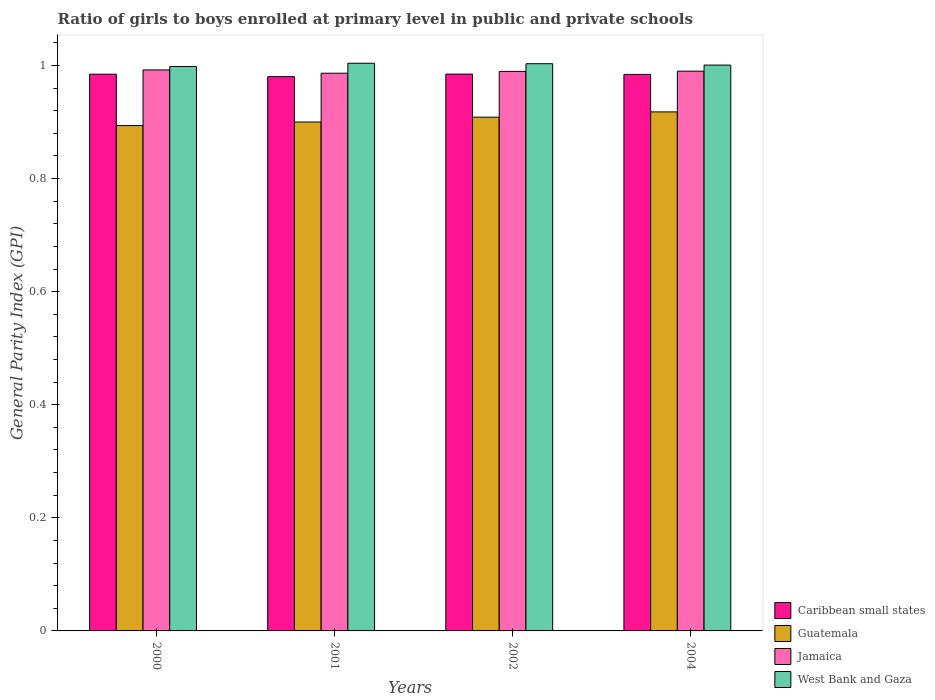How many different coloured bars are there?
Ensure brevity in your answer.  4. How many groups of bars are there?
Provide a short and direct response. 4. How many bars are there on the 2nd tick from the right?
Offer a terse response. 4. What is the general parity index in Guatemala in 2001?
Your answer should be compact. 0.9. Across all years, what is the maximum general parity index in West Bank and Gaza?
Give a very brief answer. 1. Across all years, what is the minimum general parity index in Guatemala?
Give a very brief answer. 0.89. In which year was the general parity index in Caribbean small states minimum?
Provide a succinct answer. 2001. What is the total general parity index in Jamaica in the graph?
Offer a terse response. 3.96. What is the difference between the general parity index in West Bank and Gaza in 2000 and that in 2002?
Your answer should be very brief. -0. What is the difference between the general parity index in West Bank and Gaza in 2000 and the general parity index in Caribbean small states in 2001?
Your answer should be very brief. 0.02. What is the average general parity index in Guatemala per year?
Your answer should be very brief. 0.91. In the year 2002, what is the difference between the general parity index in Jamaica and general parity index in Guatemala?
Offer a very short reply. 0.08. In how many years, is the general parity index in Jamaica greater than 0.08?
Offer a terse response. 4. What is the ratio of the general parity index in West Bank and Gaza in 2000 to that in 2004?
Make the answer very short. 1. What is the difference between the highest and the second highest general parity index in Caribbean small states?
Offer a terse response. 0. What is the difference between the highest and the lowest general parity index in Caribbean small states?
Provide a short and direct response. 0. Is it the case that in every year, the sum of the general parity index in Caribbean small states and general parity index in Jamaica is greater than the sum of general parity index in West Bank and Gaza and general parity index in Guatemala?
Offer a terse response. Yes. What does the 3rd bar from the left in 2004 represents?
Offer a very short reply. Jamaica. What does the 2nd bar from the right in 2004 represents?
Offer a terse response. Jamaica. Is it the case that in every year, the sum of the general parity index in Jamaica and general parity index in Caribbean small states is greater than the general parity index in West Bank and Gaza?
Ensure brevity in your answer.  Yes. How many bars are there?
Provide a succinct answer. 16. What is the difference between two consecutive major ticks on the Y-axis?
Give a very brief answer. 0.2. Does the graph contain any zero values?
Offer a very short reply. No. What is the title of the graph?
Your answer should be very brief. Ratio of girls to boys enrolled at primary level in public and private schools. What is the label or title of the X-axis?
Provide a short and direct response. Years. What is the label or title of the Y-axis?
Offer a terse response. General Parity Index (GPI). What is the General Parity Index (GPI) of Caribbean small states in 2000?
Make the answer very short. 0.98. What is the General Parity Index (GPI) of Guatemala in 2000?
Provide a succinct answer. 0.89. What is the General Parity Index (GPI) in Jamaica in 2000?
Make the answer very short. 0.99. What is the General Parity Index (GPI) in West Bank and Gaza in 2000?
Give a very brief answer. 1. What is the General Parity Index (GPI) in Caribbean small states in 2001?
Your response must be concise. 0.98. What is the General Parity Index (GPI) of Guatemala in 2001?
Provide a short and direct response. 0.9. What is the General Parity Index (GPI) of Jamaica in 2001?
Offer a terse response. 0.99. What is the General Parity Index (GPI) of West Bank and Gaza in 2001?
Your answer should be compact. 1. What is the General Parity Index (GPI) of Caribbean small states in 2002?
Your answer should be compact. 0.98. What is the General Parity Index (GPI) in Guatemala in 2002?
Your answer should be compact. 0.91. What is the General Parity Index (GPI) of Jamaica in 2002?
Make the answer very short. 0.99. What is the General Parity Index (GPI) in West Bank and Gaza in 2002?
Offer a very short reply. 1. What is the General Parity Index (GPI) of Caribbean small states in 2004?
Keep it short and to the point. 0.98. What is the General Parity Index (GPI) in Guatemala in 2004?
Provide a succinct answer. 0.92. What is the General Parity Index (GPI) in Jamaica in 2004?
Your answer should be very brief. 0.99. What is the General Parity Index (GPI) of West Bank and Gaza in 2004?
Give a very brief answer. 1. Across all years, what is the maximum General Parity Index (GPI) of Caribbean small states?
Ensure brevity in your answer.  0.98. Across all years, what is the maximum General Parity Index (GPI) in Guatemala?
Provide a succinct answer. 0.92. Across all years, what is the maximum General Parity Index (GPI) in Jamaica?
Ensure brevity in your answer.  0.99. Across all years, what is the maximum General Parity Index (GPI) in West Bank and Gaza?
Give a very brief answer. 1. Across all years, what is the minimum General Parity Index (GPI) of Caribbean small states?
Provide a short and direct response. 0.98. Across all years, what is the minimum General Parity Index (GPI) of Guatemala?
Offer a terse response. 0.89. Across all years, what is the minimum General Parity Index (GPI) of Jamaica?
Your answer should be very brief. 0.99. Across all years, what is the minimum General Parity Index (GPI) in West Bank and Gaza?
Your response must be concise. 1. What is the total General Parity Index (GPI) of Caribbean small states in the graph?
Keep it short and to the point. 3.93. What is the total General Parity Index (GPI) in Guatemala in the graph?
Ensure brevity in your answer.  3.62. What is the total General Parity Index (GPI) of Jamaica in the graph?
Your response must be concise. 3.96. What is the total General Parity Index (GPI) of West Bank and Gaza in the graph?
Offer a very short reply. 4.01. What is the difference between the General Parity Index (GPI) in Caribbean small states in 2000 and that in 2001?
Keep it short and to the point. 0. What is the difference between the General Parity Index (GPI) of Guatemala in 2000 and that in 2001?
Your answer should be compact. -0.01. What is the difference between the General Parity Index (GPI) in Jamaica in 2000 and that in 2001?
Make the answer very short. 0.01. What is the difference between the General Parity Index (GPI) in West Bank and Gaza in 2000 and that in 2001?
Offer a terse response. -0.01. What is the difference between the General Parity Index (GPI) in Caribbean small states in 2000 and that in 2002?
Offer a terse response. -0. What is the difference between the General Parity Index (GPI) in Guatemala in 2000 and that in 2002?
Provide a succinct answer. -0.01. What is the difference between the General Parity Index (GPI) in Jamaica in 2000 and that in 2002?
Make the answer very short. 0. What is the difference between the General Parity Index (GPI) of West Bank and Gaza in 2000 and that in 2002?
Keep it short and to the point. -0. What is the difference between the General Parity Index (GPI) of Caribbean small states in 2000 and that in 2004?
Your answer should be very brief. 0. What is the difference between the General Parity Index (GPI) of Guatemala in 2000 and that in 2004?
Give a very brief answer. -0.02. What is the difference between the General Parity Index (GPI) of Jamaica in 2000 and that in 2004?
Provide a succinct answer. 0. What is the difference between the General Parity Index (GPI) in West Bank and Gaza in 2000 and that in 2004?
Keep it short and to the point. -0. What is the difference between the General Parity Index (GPI) in Caribbean small states in 2001 and that in 2002?
Make the answer very short. -0. What is the difference between the General Parity Index (GPI) in Guatemala in 2001 and that in 2002?
Provide a short and direct response. -0.01. What is the difference between the General Parity Index (GPI) in Jamaica in 2001 and that in 2002?
Give a very brief answer. -0. What is the difference between the General Parity Index (GPI) of West Bank and Gaza in 2001 and that in 2002?
Offer a terse response. 0. What is the difference between the General Parity Index (GPI) in Caribbean small states in 2001 and that in 2004?
Keep it short and to the point. -0. What is the difference between the General Parity Index (GPI) of Guatemala in 2001 and that in 2004?
Give a very brief answer. -0.02. What is the difference between the General Parity Index (GPI) of Jamaica in 2001 and that in 2004?
Your response must be concise. -0. What is the difference between the General Parity Index (GPI) in West Bank and Gaza in 2001 and that in 2004?
Provide a short and direct response. 0. What is the difference between the General Parity Index (GPI) of Caribbean small states in 2002 and that in 2004?
Ensure brevity in your answer.  0. What is the difference between the General Parity Index (GPI) in Guatemala in 2002 and that in 2004?
Keep it short and to the point. -0.01. What is the difference between the General Parity Index (GPI) of Jamaica in 2002 and that in 2004?
Your answer should be very brief. -0. What is the difference between the General Parity Index (GPI) in West Bank and Gaza in 2002 and that in 2004?
Ensure brevity in your answer.  0. What is the difference between the General Parity Index (GPI) of Caribbean small states in 2000 and the General Parity Index (GPI) of Guatemala in 2001?
Offer a very short reply. 0.08. What is the difference between the General Parity Index (GPI) of Caribbean small states in 2000 and the General Parity Index (GPI) of Jamaica in 2001?
Provide a succinct answer. -0. What is the difference between the General Parity Index (GPI) of Caribbean small states in 2000 and the General Parity Index (GPI) of West Bank and Gaza in 2001?
Provide a short and direct response. -0.02. What is the difference between the General Parity Index (GPI) in Guatemala in 2000 and the General Parity Index (GPI) in Jamaica in 2001?
Your answer should be compact. -0.09. What is the difference between the General Parity Index (GPI) in Guatemala in 2000 and the General Parity Index (GPI) in West Bank and Gaza in 2001?
Your answer should be compact. -0.11. What is the difference between the General Parity Index (GPI) in Jamaica in 2000 and the General Parity Index (GPI) in West Bank and Gaza in 2001?
Provide a short and direct response. -0.01. What is the difference between the General Parity Index (GPI) in Caribbean small states in 2000 and the General Parity Index (GPI) in Guatemala in 2002?
Your answer should be very brief. 0.08. What is the difference between the General Parity Index (GPI) of Caribbean small states in 2000 and the General Parity Index (GPI) of Jamaica in 2002?
Make the answer very short. -0.01. What is the difference between the General Parity Index (GPI) of Caribbean small states in 2000 and the General Parity Index (GPI) of West Bank and Gaza in 2002?
Offer a very short reply. -0.02. What is the difference between the General Parity Index (GPI) in Guatemala in 2000 and the General Parity Index (GPI) in Jamaica in 2002?
Your answer should be very brief. -0.1. What is the difference between the General Parity Index (GPI) in Guatemala in 2000 and the General Parity Index (GPI) in West Bank and Gaza in 2002?
Make the answer very short. -0.11. What is the difference between the General Parity Index (GPI) of Jamaica in 2000 and the General Parity Index (GPI) of West Bank and Gaza in 2002?
Ensure brevity in your answer.  -0.01. What is the difference between the General Parity Index (GPI) in Caribbean small states in 2000 and the General Parity Index (GPI) in Guatemala in 2004?
Make the answer very short. 0.07. What is the difference between the General Parity Index (GPI) in Caribbean small states in 2000 and the General Parity Index (GPI) in Jamaica in 2004?
Your response must be concise. -0.01. What is the difference between the General Parity Index (GPI) in Caribbean small states in 2000 and the General Parity Index (GPI) in West Bank and Gaza in 2004?
Provide a succinct answer. -0.02. What is the difference between the General Parity Index (GPI) in Guatemala in 2000 and the General Parity Index (GPI) in Jamaica in 2004?
Ensure brevity in your answer.  -0.1. What is the difference between the General Parity Index (GPI) in Guatemala in 2000 and the General Parity Index (GPI) in West Bank and Gaza in 2004?
Give a very brief answer. -0.11. What is the difference between the General Parity Index (GPI) in Jamaica in 2000 and the General Parity Index (GPI) in West Bank and Gaza in 2004?
Offer a terse response. -0.01. What is the difference between the General Parity Index (GPI) of Caribbean small states in 2001 and the General Parity Index (GPI) of Guatemala in 2002?
Keep it short and to the point. 0.07. What is the difference between the General Parity Index (GPI) of Caribbean small states in 2001 and the General Parity Index (GPI) of Jamaica in 2002?
Your response must be concise. -0.01. What is the difference between the General Parity Index (GPI) in Caribbean small states in 2001 and the General Parity Index (GPI) in West Bank and Gaza in 2002?
Offer a very short reply. -0.02. What is the difference between the General Parity Index (GPI) in Guatemala in 2001 and the General Parity Index (GPI) in Jamaica in 2002?
Your answer should be compact. -0.09. What is the difference between the General Parity Index (GPI) of Guatemala in 2001 and the General Parity Index (GPI) of West Bank and Gaza in 2002?
Give a very brief answer. -0.1. What is the difference between the General Parity Index (GPI) in Jamaica in 2001 and the General Parity Index (GPI) in West Bank and Gaza in 2002?
Keep it short and to the point. -0.02. What is the difference between the General Parity Index (GPI) in Caribbean small states in 2001 and the General Parity Index (GPI) in Guatemala in 2004?
Your response must be concise. 0.06. What is the difference between the General Parity Index (GPI) in Caribbean small states in 2001 and the General Parity Index (GPI) in Jamaica in 2004?
Provide a short and direct response. -0.01. What is the difference between the General Parity Index (GPI) in Caribbean small states in 2001 and the General Parity Index (GPI) in West Bank and Gaza in 2004?
Provide a succinct answer. -0.02. What is the difference between the General Parity Index (GPI) in Guatemala in 2001 and the General Parity Index (GPI) in Jamaica in 2004?
Provide a succinct answer. -0.09. What is the difference between the General Parity Index (GPI) of Guatemala in 2001 and the General Parity Index (GPI) of West Bank and Gaza in 2004?
Your answer should be very brief. -0.1. What is the difference between the General Parity Index (GPI) of Jamaica in 2001 and the General Parity Index (GPI) of West Bank and Gaza in 2004?
Provide a succinct answer. -0.01. What is the difference between the General Parity Index (GPI) of Caribbean small states in 2002 and the General Parity Index (GPI) of Guatemala in 2004?
Make the answer very short. 0.07. What is the difference between the General Parity Index (GPI) in Caribbean small states in 2002 and the General Parity Index (GPI) in Jamaica in 2004?
Your answer should be compact. -0.01. What is the difference between the General Parity Index (GPI) of Caribbean small states in 2002 and the General Parity Index (GPI) of West Bank and Gaza in 2004?
Ensure brevity in your answer.  -0.02. What is the difference between the General Parity Index (GPI) in Guatemala in 2002 and the General Parity Index (GPI) in Jamaica in 2004?
Provide a succinct answer. -0.08. What is the difference between the General Parity Index (GPI) of Guatemala in 2002 and the General Parity Index (GPI) of West Bank and Gaza in 2004?
Your answer should be very brief. -0.09. What is the difference between the General Parity Index (GPI) of Jamaica in 2002 and the General Parity Index (GPI) of West Bank and Gaza in 2004?
Provide a succinct answer. -0.01. What is the average General Parity Index (GPI) in Caribbean small states per year?
Make the answer very short. 0.98. What is the average General Parity Index (GPI) in Guatemala per year?
Make the answer very short. 0.91. What is the average General Parity Index (GPI) in Jamaica per year?
Provide a succinct answer. 0.99. In the year 2000, what is the difference between the General Parity Index (GPI) in Caribbean small states and General Parity Index (GPI) in Guatemala?
Offer a terse response. 0.09. In the year 2000, what is the difference between the General Parity Index (GPI) in Caribbean small states and General Parity Index (GPI) in Jamaica?
Keep it short and to the point. -0.01. In the year 2000, what is the difference between the General Parity Index (GPI) in Caribbean small states and General Parity Index (GPI) in West Bank and Gaza?
Make the answer very short. -0.01. In the year 2000, what is the difference between the General Parity Index (GPI) in Guatemala and General Parity Index (GPI) in Jamaica?
Keep it short and to the point. -0.1. In the year 2000, what is the difference between the General Parity Index (GPI) of Guatemala and General Parity Index (GPI) of West Bank and Gaza?
Keep it short and to the point. -0.1. In the year 2000, what is the difference between the General Parity Index (GPI) of Jamaica and General Parity Index (GPI) of West Bank and Gaza?
Make the answer very short. -0.01. In the year 2001, what is the difference between the General Parity Index (GPI) of Caribbean small states and General Parity Index (GPI) of Guatemala?
Your answer should be very brief. 0.08. In the year 2001, what is the difference between the General Parity Index (GPI) of Caribbean small states and General Parity Index (GPI) of Jamaica?
Offer a very short reply. -0.01. In the year 2001, what is the difference between the General Parity Index (GPI) in Caribbean small states and General Parity Index (GPI) in West Bank and Gaza?
Provide a short and direct response. -0.02. In the year 2001, what is the difference between the General Parity Index (GPI) in Guatemala and General Parity Index (GPI) in Jamaica?
Ensure brevity in your answer.  -0.09. In the year 2001, what is the difference between the General Parity Index (GPI) of Guatemala and General Parity Index (GPI) of West Bank and Gaza?
Give a very brief answer. -0.1. In the year 2001, what is the difference between the General Parity Index (GPI) in Jamaica and General Parity Index (GPI) in West Bank and Gaza?
Provide a short and direct response. -0.02. In the year 2002, what is the difference between the General Parity Index (GPI) of Caribbean small states and General Parity Index (GPI) of Guatemala?
Offer a very short reply. 0.08. In the year 2002, what is the difference between the General Parity Index (GPI) of Caribbean small states and General Parity Index (GPI) of Jamaica?
Your response must be concise. -0. In the year 2002, what is the difference between the General Parity Index (GPI) in Caribbean small states and General Parity Index (GPI) in West Bank and Gaza?
Ensure brevity in your answer.  -0.02. In the year 2002, what is the difference between the General Parity Index (GPI) in Guatemala and General Parity Index (GPI) in Jamaica?
Your answer should be very brief. -0.08. In the year 2002, what is the difference between the General Parity Index (GPI) in Guatemala and General Parity Index (GPI) in West Bank and Gaza?
Give a very brief answer. -0.09. In the year 2002, what is the difference between the General Parity Index (GPI) in Jamaica and General Parity Index (GPI) in West Bank and Gaza?
Give a very brief answer. -0.01. In the year 2004, what is the difference between the General Parity Index (GPI) of Caribbean small states and General Parity Index (GPI) of Guatemala?
Your response must be concise. 0.07. In the year 2004, what is the difference between the General Parity Index (GPI) in Caribbean small states and General Parity Index (GPI) in Jamaica?
Keep it short and to the point. -0.01. In the year 2004, what is the difference between the General Parity Index (GPI) in Caribbean small states and General Parity Index (GPI) in West Bank and Gaza?
Your response must be concise. -0.02. In the year 2004, what is the difference between the General Parity Index (GPI) of Guatemala and General Parity Index (GPI) of Jamaica?
Make the answer very short. -0.07. In the year 2004, what is the difference between the General Parity Index (GPI) of Guatemala and General Parity Index (GPI) of West Bank and Gaza?
Your answer should be compact. -0.08. In the year 2004, what is the difference between the General Parity Index (GPI) in Jamaica and General Parity Index (GPI) in West Bank and Gaza?
Offer a very short reply. -0.01. What is the ratio of the General Parity Index (GPI) in Guatemala in 2000 to that in 2001?
Offer a terse response. 0.99. What is the ratio of the General Parity Index (GPI) of Jamaica in 2000 to that in 2001?
Your answer should be very brief. 1.01. What is the ratio of the General Parity Index (GPI) of West Bank and Gaza in 2000 to that in 2001?
Offer a very short reply. 0.99. What is the ratio of the General Parity Index (GPI) in Guatemala in 2000 to that in 2002?
Give a very brief answer. 0.98. What is the ratio of the General Parity Index (GPI) of Jamaica in 2000 to that in 2002?
Provide a short and direct response. 1. What is the ratio of the General Parity Index (GPI) of Caribbean small states in 2000 to that in 2004?
Your answer should be very brief. 1. What is the ratio of the General Parity Index (GPI) in Guatemala in 2000 to that in 2004?
Make the answer very short. 0.97. What is the ratio of the General Parity Index (GPI) in Guatemala in 2001 to that in 2002?
Provide a succinct answer. 0.99. What is the ratio of the General Parity Index (GPI) of Jamaica in 2001 to that in 2002?
Ensure brevity in your answer.  1. What is the ratio of the General Parity Index (GPI) of West Bank and Gaza in 2001 to that in 2002?
Offer a very short reply. 1. What is the ratio of the General Parity Index (GPI) in Guatemala in 2001 to that in 2004?
Your answer should be very brief. 0.98. What is the ratio of the General Parity Index (GPI) of Jamaica in 2001 to that in 2004?
Provide a short and direct response. 1. What is the ratio of the General Parity Index (GPI) of West Bank and Gaza in 2001 to that in 2004?
Offer a very short reply. 1. What is the ratio of the General Parity Index (GPI) in Caribbean small states in 2002 to that in 2004?
Offer a terse response. 1. What is the ratio of the General Parity Index (GPI) in Guatemala in 2002 to that in 2004?
Provide a succinct answer. 0.99. What is the ratio of the General Parity Index (GPI) of Jamaica in 2002 to that in 2004?
Ensure brevity in your answer.  1. What is the ratio of the General Parity Index (GPI) of West Bank and Gaza in 2002 to that in 2004?
Make the answer very short. 1. What is the difference between the highest and the second highest General Parity Index (GPI) of Guatemala?
Offer a very short reply. 0.01. What is the difference between the highest and the second highest General Parity Index (GPI) of Jamaica?
Offer a terse response. 0. What is the difference between the highest and the second highest General Parity Index (GPI) in West Bank and Gaza?
Your response must be concise. 0. What is the difference between the highest and the lowest General Parity Index (GPI) in Caribbean small states?
Provide a short and direct response. 0. What is the difference between the highest and the lowest General Parity Index (GPI) in Guatemala?
Offer a terse response. 0.02. What is the difference between the highest and the lowest General Parity Index (GPI) in Jamaica?
Offer a terse response. 0.01. What is the difference between the highest and the lowest General Parity Index (GPI) of West Bank and Gaza?
Your response must be concise. 0.01. 